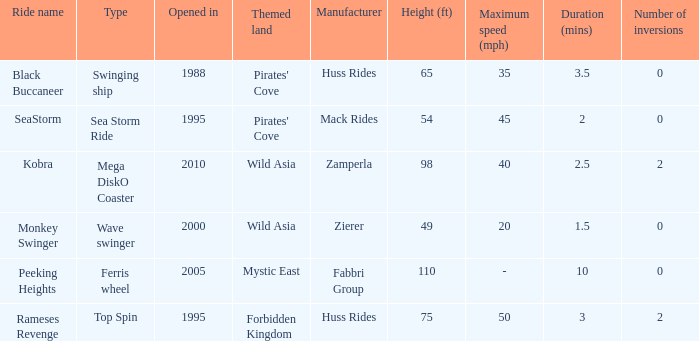What type of ride is Rameses Revenge? Top Spin. 